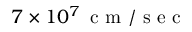<formula> <loc_0><loc_0><loc_500><loc_500>7 \times 1 0 ^ { 7 } \, c m / s e c</formula> 